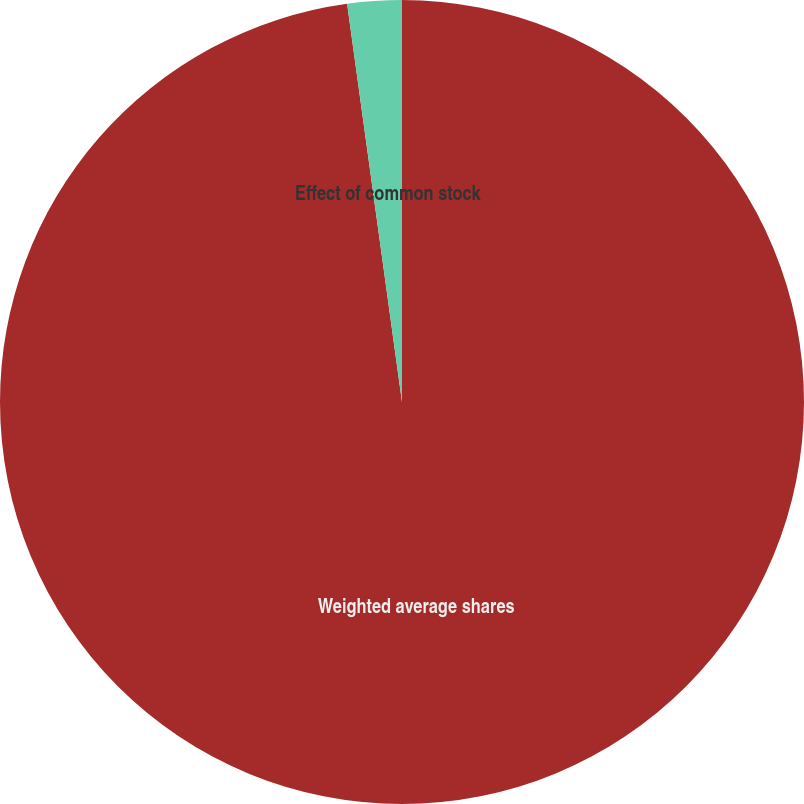Convert chart to OTSL. <chart><loc_0><loc_0><loc_500><loc_500><pie_chart><fcel>Weighted average shares<fcel>Effect of common stock<nl><fcel>97.82%<fcel>2.18%<nl></chart> 